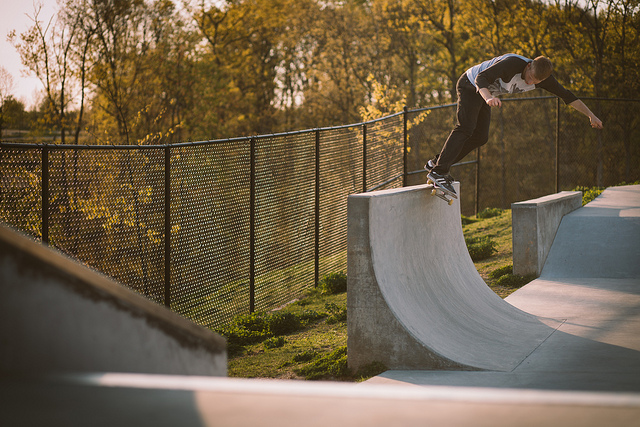What is the person doing in the image? The person is performing a skateboarding trick on a half-pipe ramp, showcasing skill and balance. What time of day does it seem to be? Given the long shadows and warm light, it appears to be late afternoon or early evening. 